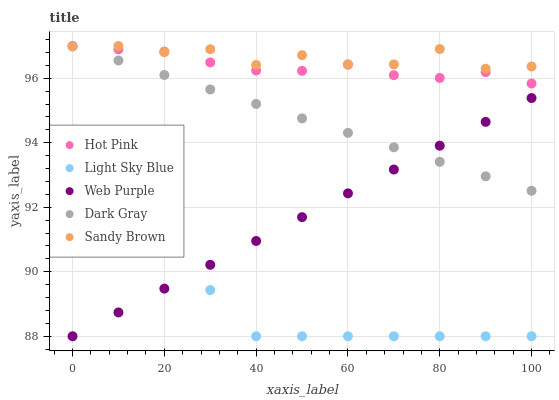Does Light Sky Blue have the minimum area under the curve?
Answer yes or no. Yes. Does Sandy Brown have the maximum area under the curve?
Answer yes or no. Yes. Does Web Purple have the minimum area under the curve?
Answer yes or no. No. Does Web Purple have the maximum area under the curve?
Answer yes or no. No. Is Dark Gray the smoothest?
Answer yes or no. Yes. Is Sandy Brown the roughest?
Answer yes or no. Yes. Is Web Purple the smoothest?
Answer yes or no. No. Is Web Purple the roughest?
Answer yes or no. No. Does Web Purple have the lowest value?
Answer yes or no. Yes. Does Hot Pink have the lowest value?
Answer yes or no. No. Does Sandy Brown have the highest value?
Answer yes or no. Yes. Does Web Purple have the highest value?
Answer yes or no. No. Is Light Sky Blue less than Dark Gray?
Answer yes or no. Yes. Is Dark Gray greater than Light Sky Blue?
Answer yes or no. Yes. Does Sandy Brown intersect Hot Pink?
Answer yes or no. Yes. Is Sandy Brown less than Hot Pink?
Answer yes or no. No. Is Sandy Brown greater than Hot Pink?
Answer yes or no. No. Does Light Sky Blue intersect Dark Gray?
Answer yes or no. No. 